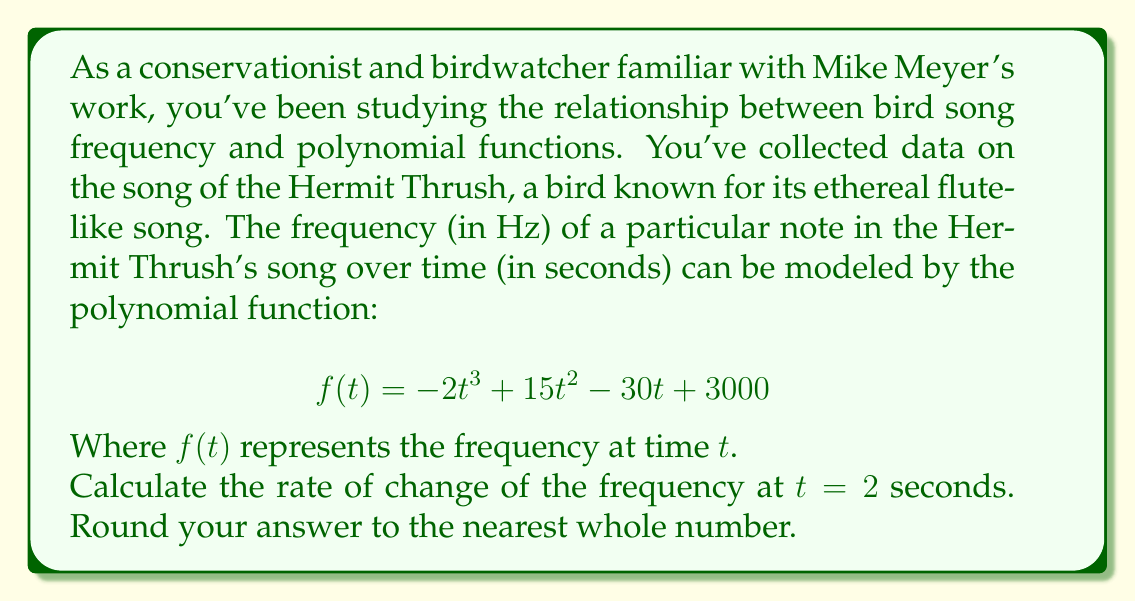Could you help me with this problem? To find the rate of change of the frequency at a specific point, we need to calculate the derivative of the function $f(t)$ and then evaluate it at $t = 2$.

1) First, let's find the derivative of $f(t)$:
   $$ f(t) = -2t^3 + 15t^2 - 30t + 3000 $$
   $$ f'(t) = -6t^2 + 30t - 30 $$

2) Now, we need to evaluate $f'(t)$ at $t = 2$:
   $$ f'(2) = -6(2)^2 + 30(2) - 30 $$
   $$ = -6(4) + 60 - 30 $$
   $$ = -24 + 60 - 30 $$
   $$ = 6 $$

3) The rate of change at $t = 2$ is 6 Hz/second.

4) Since the question asks to round to the nearest whole number, the final answer is 6.

This positive rate of change indicates that at $t = 2$ seconds, the frequency of the Hermit Thrush's song is increasing at a rate of 6 Hz per second.
Answer: 6 Hz/second 